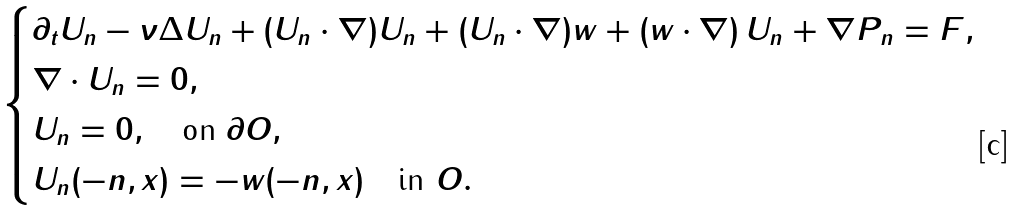Convert formula to latex. <formula><loc_0><loc_0><loc_500><loc_500>\begin{cases} \partial _ { t } U _ { n } - \nu \Delta U _ { n } + ( U _ { n } \cdot \nabla ) U _ { n } + ( U _ { n } \cdot \nabla ) w + ( w \cdot \nabla ) \, U _ { n } + \nabla P _ { n } = F , \\ \nabla \cdot U _ { n } = 0 , \\ U _ { n } = 0 , \quad \text {on } \partial O , \\ U _ { n } ( - n , x ) = - w ( - n , x ) \quad \text {in } O . \end{cases}</formula> 